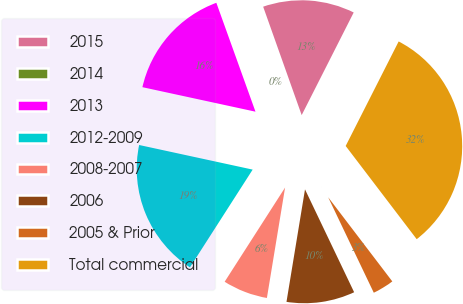<chart> <loc_0><loc_0><loc_500><loc_500><pie_chart><fcel>2015<fcel>2014<fcel>2013<fcel>2012-2009<fcel>2008-2007<fcel>2006<fcel>2005 & Prior<fcel>Total commercial<nl><fcel>12.9%<fcel>0.06%<fcel>16.11%<fcel>19.32%<fcel>6.48%<fcel>9.69%<fcel>3.27%<fcel>32.17%<nl></chart> 